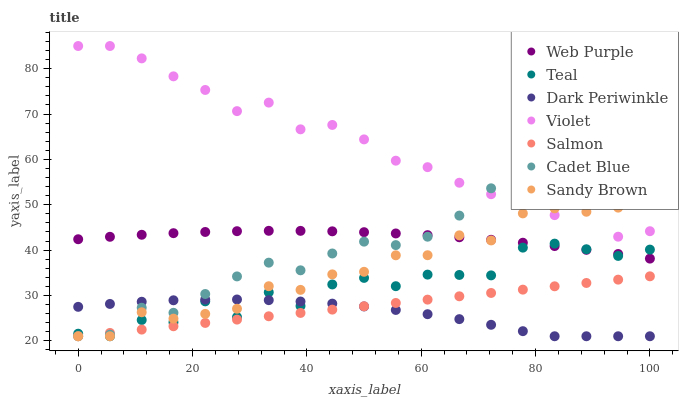Does Dark Periwinkle have the minimum area under the curve?
Answer yes or no. Yes. Does Violet have the maximum area under the curve?
Answer yes or no. Yes. Does Salmon have the minimum area under the curve?
Answer yes or no. No. Does Salmon have the maximum area under the curve?
Answer yes or no. No. Is Salmon the smoothest?
Answer yes or no. Yes. Is Teal the roughest?
Answer yes or no. Yes. Is Web Purple the smoothest?
Answer yes or no. No. Is Web Purple the roughest?
Answer yes or no. No. Does Cadet Blue have the lowest value?
Answer yes or no. Yes. Does Web Purple have the lowest value?
Answer yes or no. No. Does Violet have the highest value?
Answer yes or no. Yes. Does Salmon have the highest value?
Answer yes or no. No. Is Dark Periwinkle less than Violet?
Answer yes or no. Yes. Is Violet greater than Web Purple?
Answer yes or no. Yes. Does Sandy Brown intersect Cadet Blue?
Answer yes or no. Yes. Is Sandy Brown less than Cadet Blue?
Answer yes or no. No. Is Sandy Brown greater than Cadet Blue?
Answer yes or no. No. Does Dark Periwinkle intersect Violet?
Answer yes or no. No. 